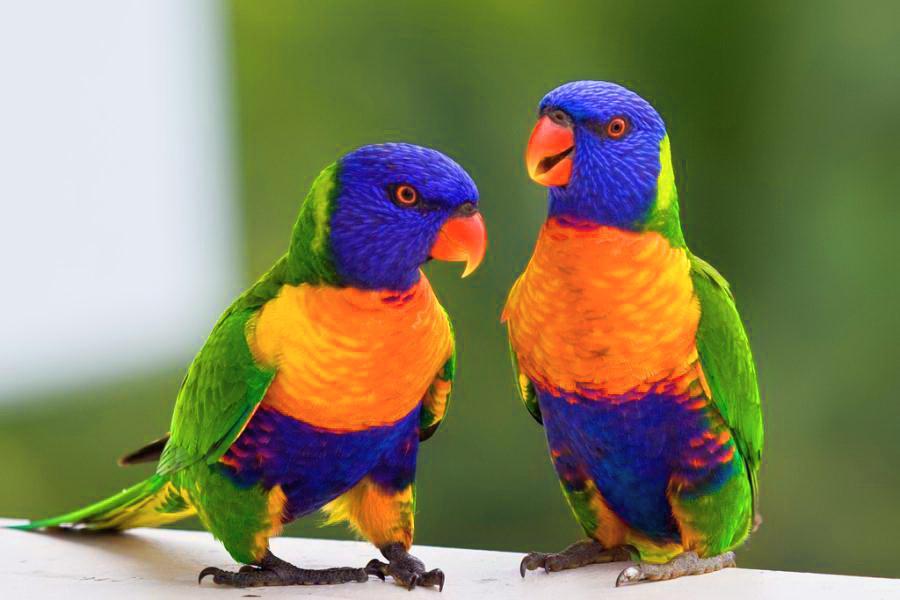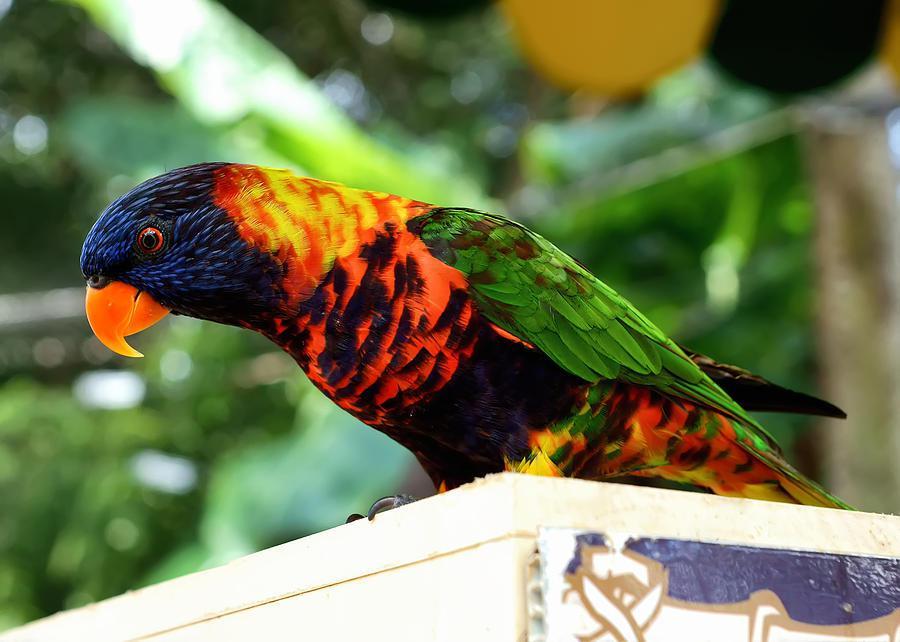The first image is the image on the left, the second image is the image on the right. For the images shown, is this caption "There are no more than 3 birds." true? Answer yes or no. Yes. 